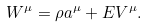Convert formula to latex. <formula><loc_0><loc_0><loc_500><loc_500>W ^ { \mu } = \rho a ^ { \mu } + E V ^ { \mu } .</formula> 